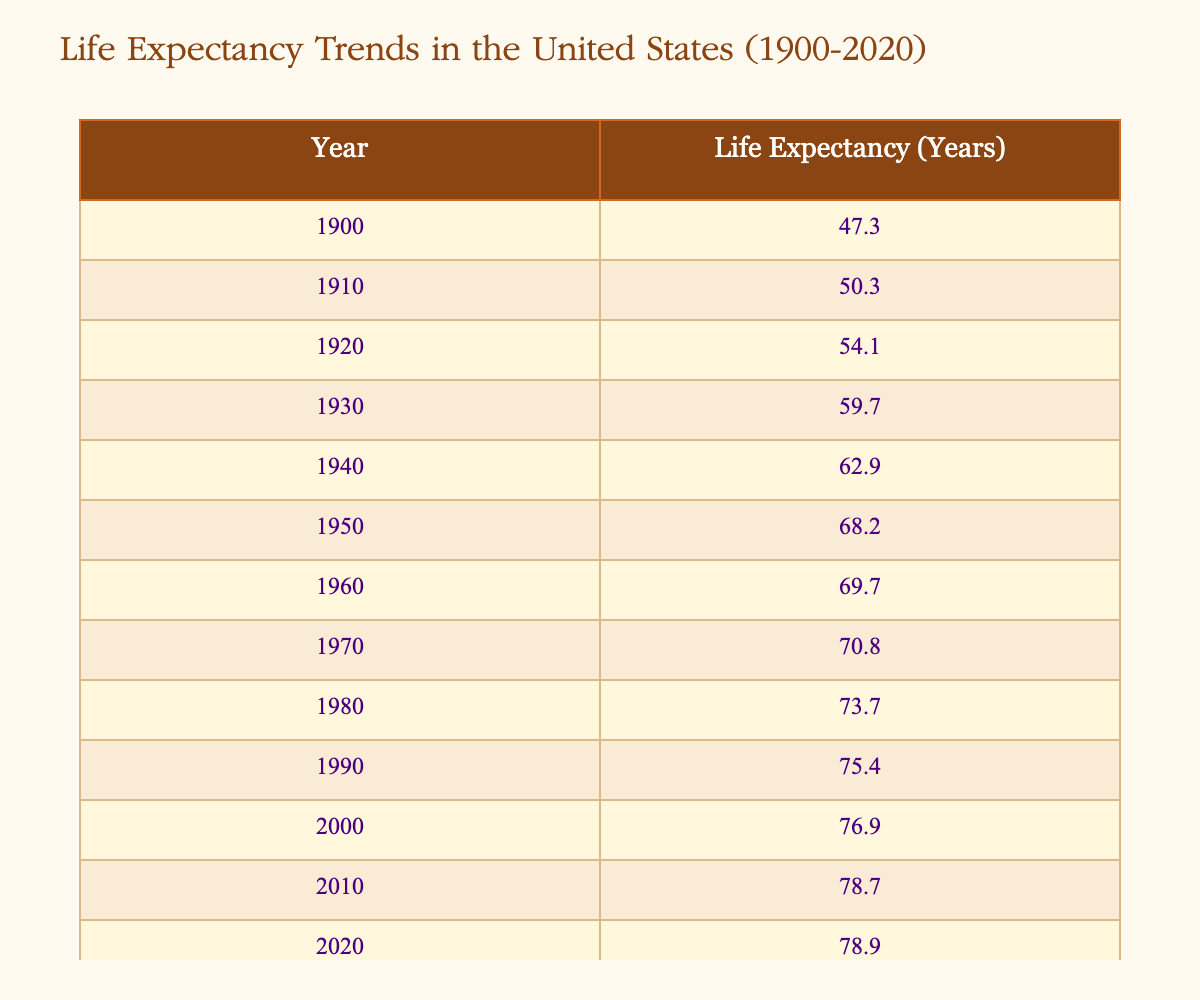What was the life expectancy in the year 1950? From the table, the row corresponding to the year 1950 shows a life expectancy of 68.2 years.
Answer: 68.2 In which year did life expectancy exceed 70 years for the first time? By examining the values in the table, life expectancy first exceeded 70 years in 1970, with a value of 70.8 years.
Answer: 1970 What is the difference in life expectancy between 1920 and 1940? The life expectancy in 1920 was 54.1 years, and in 1940 it was 62.9 years. The difference is calculated as 62.9 - 54.1 = 8.8 years.
Answer: 8.8 Is the life expectancy in 2010 greater than the average life expectancy from 1900 to 2020? To find this, first, we sum the life expectancies from 1900 to 2020 (adding all the values) which gives us a total of 1,419.5 years for 12 years, thus the average is 1,419.5 / 12 = 118.29 years. Since 78.7 (2010) is less than 118.29, the statement is false.
Answer: No What is the trend of life expectancy in the United States from 1900 to 2020? To assess the trend, we need to look at the data points in the table from 1900 to 2020. The general trend indicates a consistent increase in life expectancy, moving from 47.3 years in 1900 to 78.9 years in 2020. This suggests a positive growth trend over the entire period.
Answer: Increasing How much did life expectancy increase from 2000 to 2020? The life expectancy in the year 2000 was 76.9 years and in 2020 it was 78.9 years. The increase is calculated as 78.9 - 76.9 = 2 years.
Answer: 2 In which decade was the life expectancy lowest, and what was its value? By reviewing the rows in the table, the life expectancy was lowest in the 1900s at 47.3 years (in 1900).
Answer: 1900, 47.3 Was there a time when life expectancy stayed the same from one year to the next? Examining the data, there are no consecutive years in the table where the life expectancy value is identical; it continuously increases.
Answer: No 